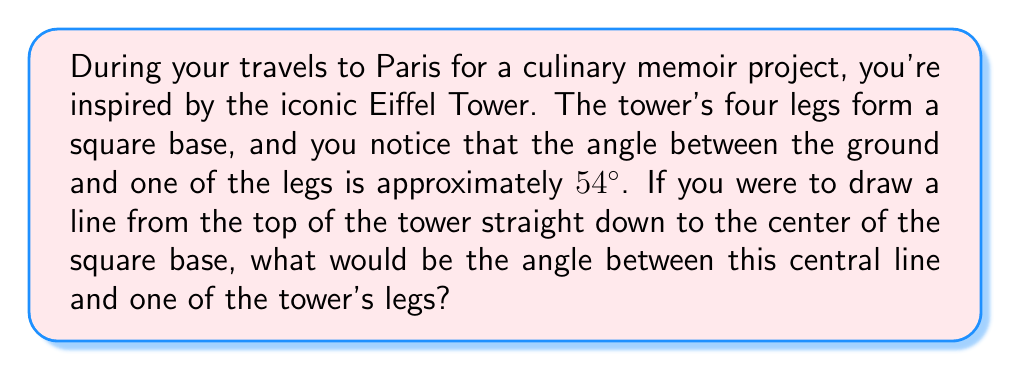Help me with this question. Let's approach this step-by-step:

1) First, let's visualize the problem:
[asy]
import geometry;

size(200);

pair A=(0,0), B=(2,0), C=(1,3), D=(1,0);
draw(A--B--C--cycle);
draw(D--C,dashed);

label("A",A,SW);
label("B",B,SE);
label("C",C,N);
label("D",D,S);

label("54°",A,NE);
label("$\theta$",C,SW);

draw(arc(A,0.3,0,54),Arrow);
draw(arc(C,0.3,270,306),Arrow);
[/asy]

2) In this diagram, AC represents one of the Eiffel Tower's legs, DC is the central line from the top to the base center, and we need to find angle $\theta$.

3) We know that the base is a square, so triangle ADB is a right-angled isosceles triangle. This means that angle DAB is 45°.

4) We're given that the angle between the ground and the leg (angle CAB) is 54°.

5) The difference between these angles is: $54° - 45° = 9°$

6) This 9° represents the angle between the leg and a line from A to C that would be perpendicular to DC.

7) In a right-angled triangle, the angles must sum to 90°. So if one angle is 9°, the other (our $\theta$) must be:

   $\theta = 90° - 9° = 81°$

Therefore, the angle between the central line and one of the tower's legs is 81°.
Answer: 81° 